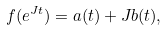<formula> <loc_0><loc_0><loc_500><loc_500>f ( e ^ { J t } ) = a ( t ) + J b ( t ) ,</formula> 